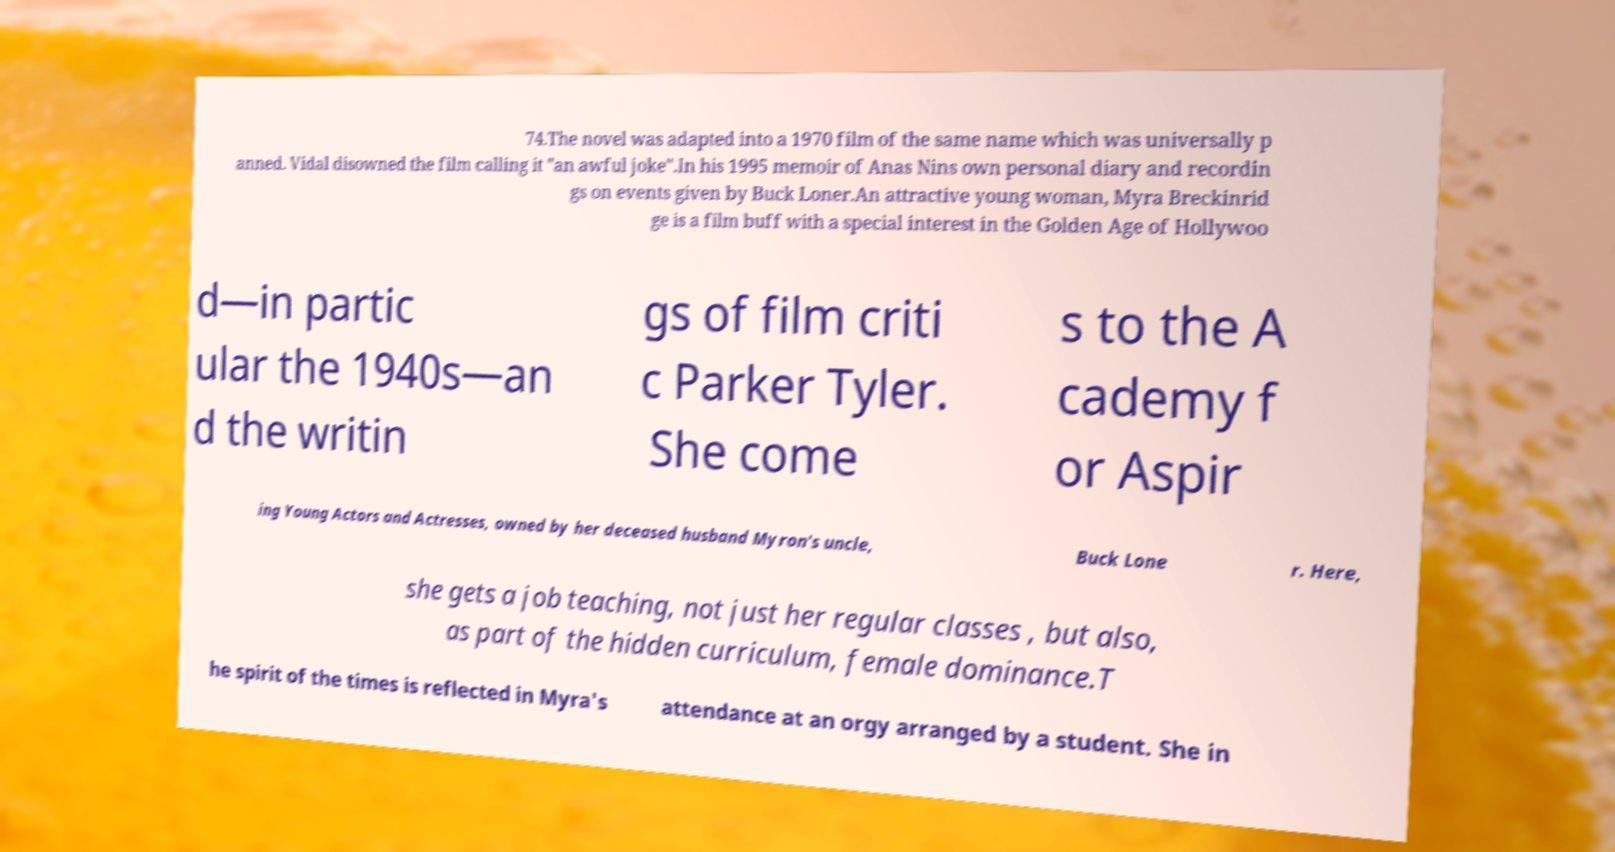Please identify and transcribe the text found in this image. 74.The novel was adapted into a 1970 film of the same name which was universally p anned. Vidal disowned the film calling it "an awful joke".In his 1995 memoir of Anas Nins own personal diary and recordin gs on events given by Buck Loner.An attractive young woman, Myra Breckinrid ge is a film buff with a special interest in the Golden Age of Hollywoo d—in partic ular the 1940s—an d the writin gs of film criti c Parker Tyler. She come s to the A cademy f or Aspir ing Young Actors and Actresses, owned by her deceased husband Myron's uncle, Buck Lone r. Here, she gets a job teaching, not just her regular classes , but also, as part of the hidden curriculum, female dominance.T he spirit of the times is reflected in Myra's attendance at an orgy arranged by a student. She in 